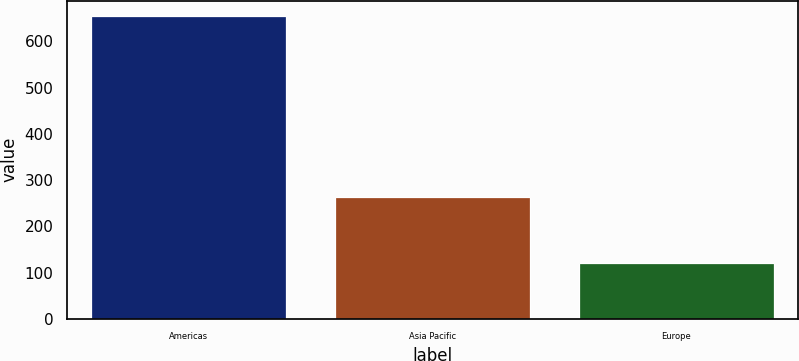Convert chart. <chart><loc_0><loc_0><loc_500><loc_500><bar_chart><fcel>Americas<fcel>Asia Pacific<fcel>Europe<nl><fcel>655.4<fcel>264.5<fcel>120.7<nl></chart> 